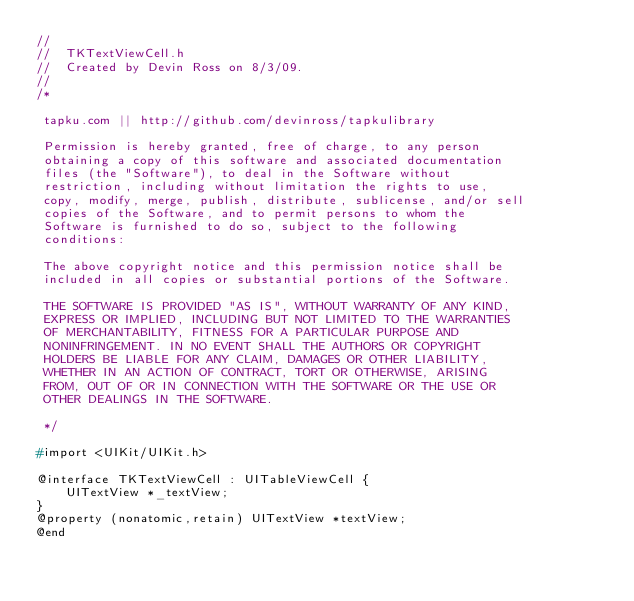Convert code to text. <code><loc_0><loc_0><loc_500><loc_500><_C_>//
//  TKTextViewCell.h
//  Created by Devin Ross on 8/3/09.
//
/*
 
 tapku.com || http://github.com/devinross/tapkulibrary
 
 Permission is hereby granted, free of charge, to any person
 obtaining a copy of this software and associated documentation
 files (the "Software"), to deal in the Software without
 restriction, including without limitation the rights to use,
 copy, modify, merge, publish, distribute, sublicense, and/or sell
 copies of the Software, and to permit persons to whom the
 Software is furnished to do so, subject to the following
 conditions:
 
 The above copyright notice and this permission notice shall be
 included in all copies or substantial portions of the Software.
 
 THE SOFTWARE IS PROVIDED "AS IS", WITHOUT WARRANTY OF ANY KIND,
 EXPRESS OR IMPLIED, INCLUDING BUT NOT LIMITED TO THE WARRANTIES
 OF MERCHANTABILITY, FITNESS FOR A PARTICULAR PURPOSE AND
 NONINFRINGEMENT. IN NO EVENT SHALL THE AUTHORS OR COPYRIGHT
 HOLDERS BE LIABLE FOR ANY CLAIM, DAMAGES OR OTHER LIABILITY,
 WHETHER IN AN ACTION OF CONTRACT, TORT OR OTHERWISE, ARISING
 FROM, OUT OF OR IN CONNECTION WITH THE SOFTWARE OR THE USE OR
 OTHER DEALINGS IN THE SOFTWARE.
 
 */

#import <UIKit/UIKit.h>

@interface TKTextViewCell : UITableViewCell {
	UITextView *_textView;
}
@property (nonatomic,retain) UITextView *textView;
@end
</code> 